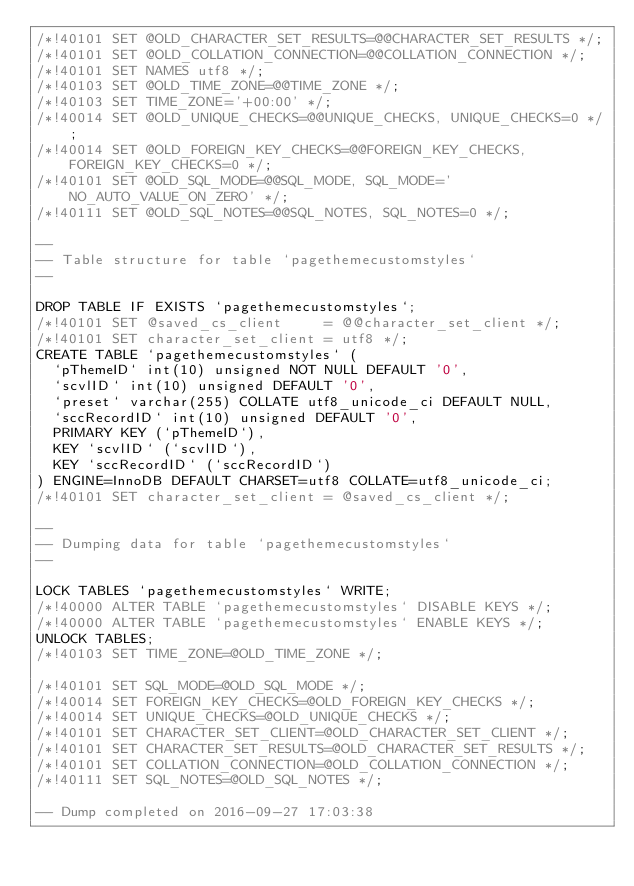Convert code to text. <code><loc_0><loc_0><loc_500><loc_500><_SQL_>/*!40101 SET @OLD_CHARACTER_SET_RESULTS=@@CHARACTER_SET_RESULTS */;
/*!40101 SET @OLD_COLLATION_CONNECTION=@@COLLATION_CONNECTION */;
/*!40101 SET NAMES utf8 */;
/*!40103 SET @OLD_TIME_ZONE=@@TIME_ZONE */;
/*!40103 SET TIME_ZONE='+00:00' */;
/*!40014 SET @OLD_UNIQUE_CHECKS=@@UNIQUE_CHECKS, UNIQUE_CHECKS=0 */;
/*!40014 SET @OLD_FOREIGN_KEY_CHECKS=@@FOREIGN_KEY_CHECKS, FOREIGN_KEY_CHECKS=0 */;
/*!40101 SET @OLD_SQL_MODE=@@SQL_MODE, SQL_MODE='NO_AUTO_VALUE_ON_ZERO' */;
/*!40111 SET @OLD_SQL_NOTES=@@SQL_NOTES, SQL_NOTES=0 */;

--
-- Table structure for table `pagethemecustomstyles`
--

DROP TABLE IF EXISTS `pagethemecustomstyles`;
/*!40101 SET @saved_cs_client     = @@character_set_client */;
/*!40101 SET character_set_client = utf8 */;
CREATE TABLE `pagethemecustomstyles` (
  `pThemeID` int(10) unsigned NOT NULL DEFAULT '0',
  `scvlID` int(10) unsigned DEFAULT '0',
  `preset` varchar(255) COLLATE utf8_unicode_ci DEFAULT NULL,
  `sccRecordID` int(10) unsigned DEFAULT '0',
  PRIMARY KEY (`pThemeID`),
  KEY `scvlID` (`scvlID`),
  KEY `sccRecordID` (`sccRecordID`)
) ENGINE=InnoDB DEFAULT CHARSET=utf8 COLLATE=utf8_unicode_ci;
/*!40101 SET character_set_client = @saved_cs_client */;

--
-- Dumping data for table `pagethemecustomstyles`
--

LOCK TABLES `pagethemecustomstyles` WRITE;
/*!40000 ALTER TABLE `pagethemecustomstyles` DISABLE KEYS */;
/*!40000 ALTER TABLE `pagethemecustomstyles` ENABLE KEYS */;
UNLOCK TABLES;
/*!40103 SET TIME_ZONE=@OLD_TIME_ZONE */;

/*!40101 SET SQL_MODE=@OLD_SQL_MODE */;
/*!40014 SET FOREIGN_KEY_CHECKS=@OLD_FOREIGN_KEY_CHECKS */;
/*!40014 SET UNIQUE_CHECKS=@OLD_UNIQUE_CHECKS */;
/*!40101 SET CHARACTER_SET_CLIENT=@OLD_CHARACTER_SET_CLIENT */;
/*!40101 SET CHARACTER_SET_RESULTS=@OLD_CHARACTER_SET_RESULTS */;
/*!40101 SET COLLATION_CONNECTION=@OLD_COLLATION_CONNECTION */;
/*!40111 SET SQL_NOTES=@OLD_SQL_NOTES */;

-- Dump completed on 2016-09-27 17:03:38
</code> 